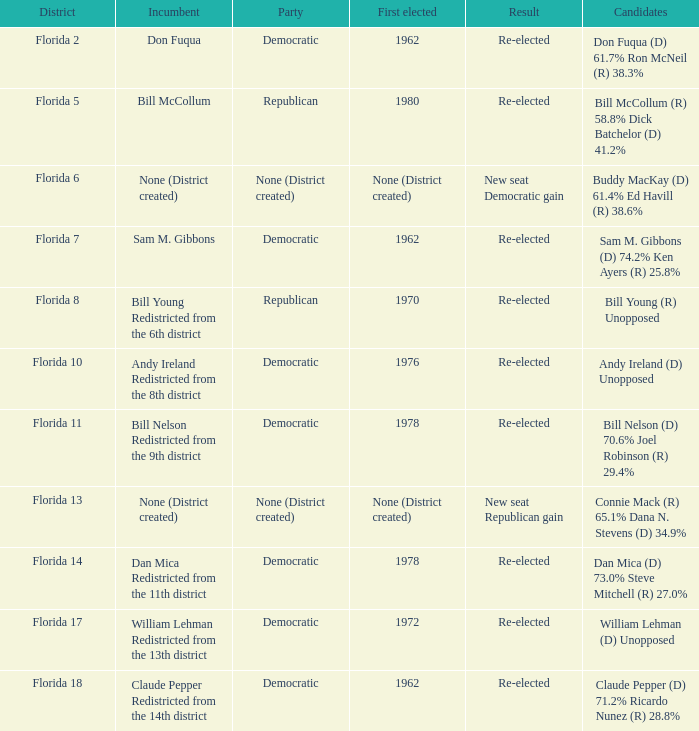Who are the nominees with the incumbent being don fuqua? Don Fuqua (D) 61.7% Ron McNeil (R) 38.3%. Give me the full table as a dictionary. {'header': ['District', 'Incumbent', 'Party', 'First elected', 'Result', 'Candidates'], 'rows': [['Florida 2', 'Don Fuqua', 'Democratic', '1962', 'Re-elected', 'Don Fuqua (D) 61.7% Ron McNeil (R) 38.3%'], ['Florida 5', 'Bill McCollum', 'Republican', '1980', 'Re-elected', 'Bill McCollum (R) 58.8% Dick Batchelor (D) 41.2%'], ['Florida 6', 'None (District created)', 'None (District created)', 'None (District created)', 'New seat Democratic gain', 'Buddy MacKay (D) 61.4% Ed Havill (R) 38.6%'], ['Florida 7', 'Sam M. Gibbons', 'Democratic', '1962', 'Re-elected', 'Sam M. Gibbons (D) 74.2% Ken Ayers (R) 25.8%'], ['Florida 8', 'Bill Young Redistricted from the 6th district', 'Republican', '1970', 'Re-elected', 'Bill Young (R) Unopposed'], ['Florida 10', 'Andy Ireland Redistricted from the 8th district', 'Democratic', '1976', 'Re-elected', 'Andy Ireland (D) Unopposed'], ['Florida 11', 'Bill Nelson Redistricted from the 9th district', 'Democratic', '1978', 'Re-elected', 'Bill Nelson (D) 70.6% Joel Robinson (R) 29.4%'], ['Florida 13', 'None (District created)', 'None (District created)', 'None (District created)', 'New seat Republican gain', 'Connie Mack (R) 65.1% Dana N. Stevens (D) 34.9%'], ['Florida 14', 'Dan Mica Redistricted from the 11th district', 'Democratic', '1978', 'Re-elected', 'Dan Mica (D) 73.0% Steve Mitchell (R) 27.0%'], ['Florida 17', 'William Lehman Redistricted from the 13th district', 'Democratic', '1972', 'Re-elected', 'William Lehman (D) Unopposed'], ['Florida 18', 'Claude Pepper Redistricted from the 14th district', 'Democratic', '1962', 'Re-elected', 'Claude Pepper (D) 71.2% Ricardo Nunez (R) 28.8%']]} 